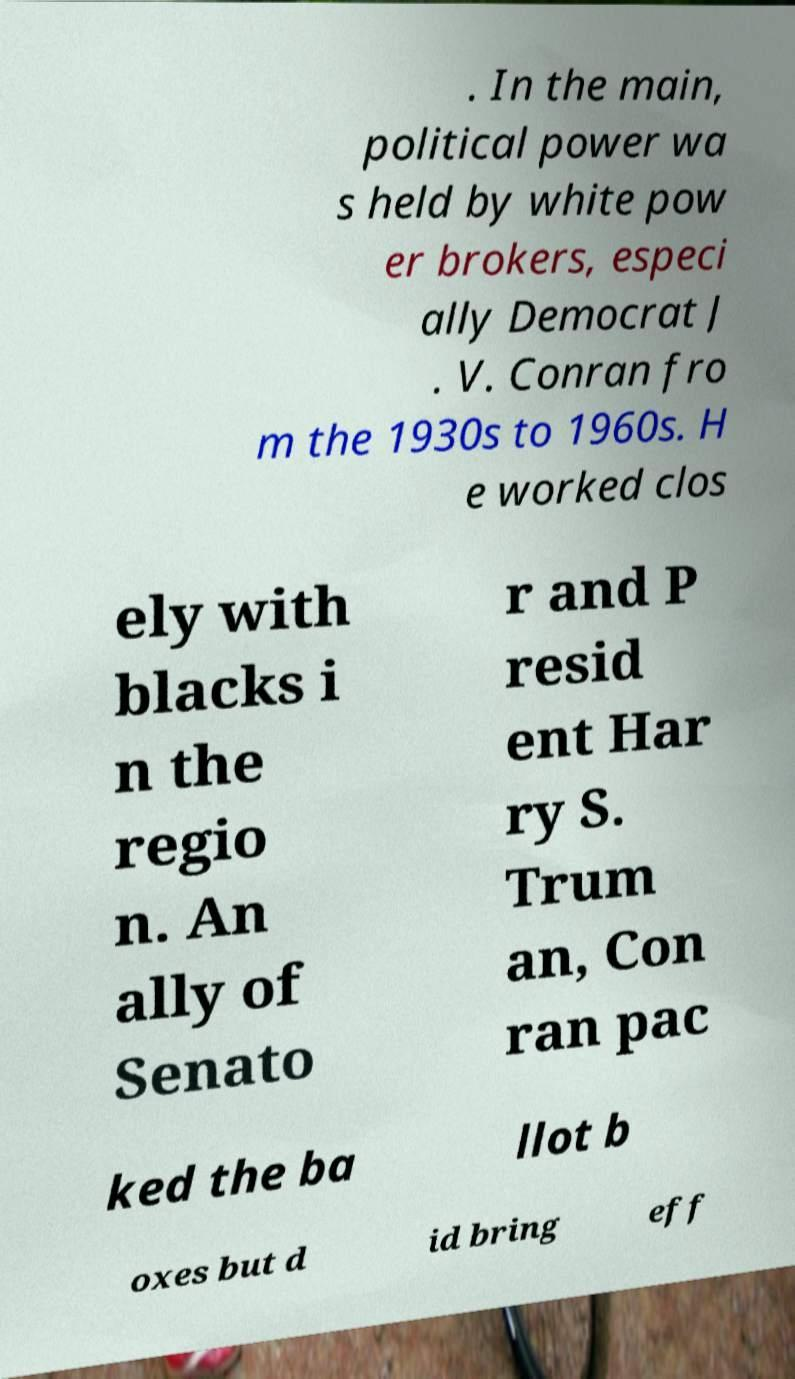There's text embedded in this image that I need extracted. Can you transcribe it verbatim? . In the main, political power wa s held by white pow er brokers, especi ally Democrat J . V. Conran fro m the 1930s to 1960s. H e worked clos ely with blacks i n the regio n. An ally of Senato r and P resid ent Har ry S. Trum an, Con ran pac ked the ba llot b oxes but d id bring eff 